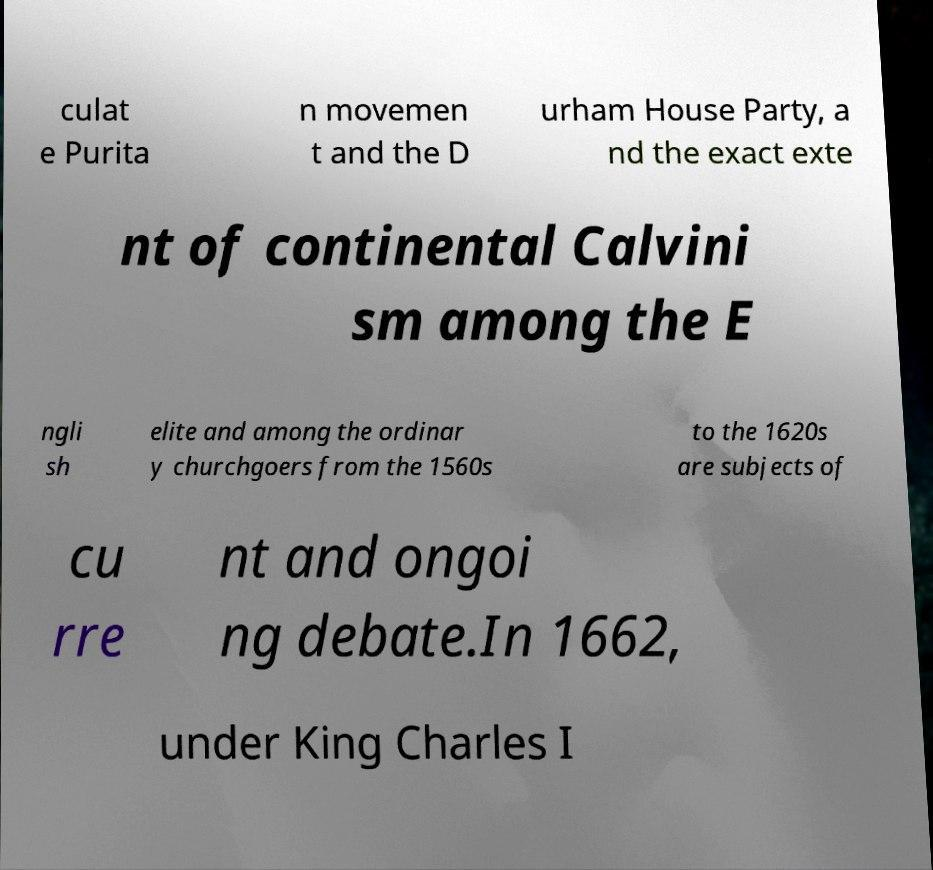Please read and relay the text visible in this image. What does it say? culat e Purita n movemen t and the D urham House Party, a nd the exact exte nt of continental Calvini sm among the E ngli sh elite and among the ordinar y churchgoers from the 1560s to the 1620s are subjects of cu rre nt and ongoi ng debate.In 1662, under King Charles I 